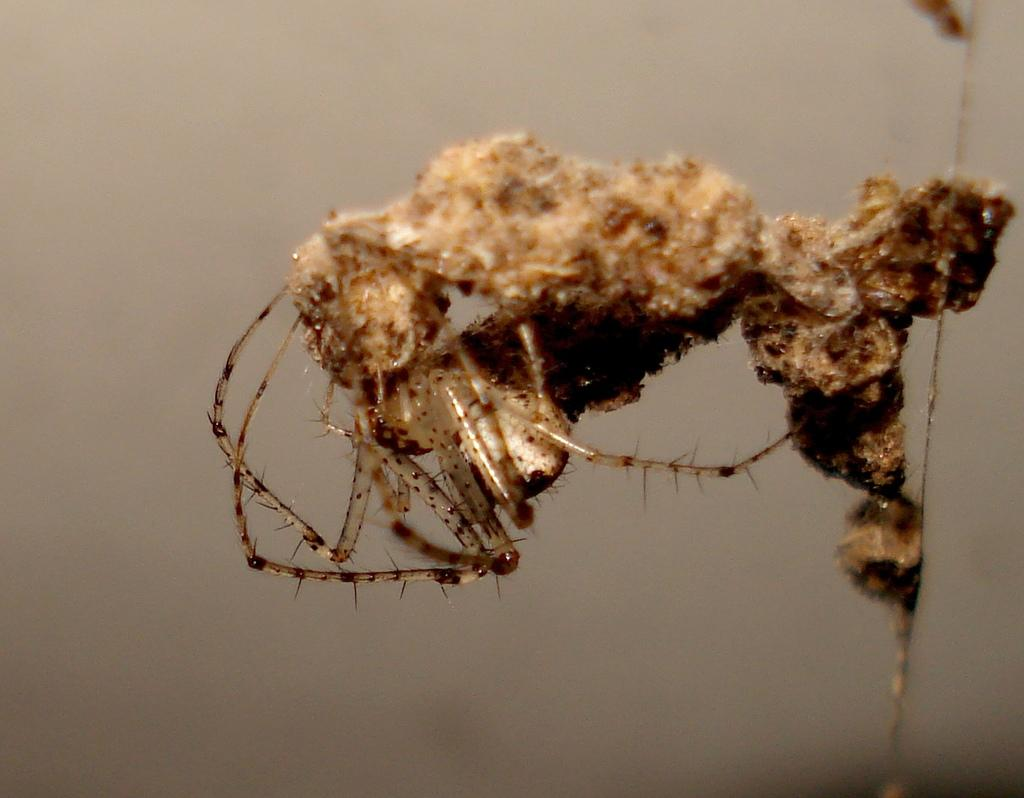What type of creature can be seen in the image? There is an insect in the image. Can you describe the background of the image? The background of the image is blurry. What type of table is visible in the image? There is no table present in the image. Can you tell me how many turkeys are in the image? There are no turkeys present in the image. What is the air quality like in the image? The provided facts do not give any information about the air quality in the image. 